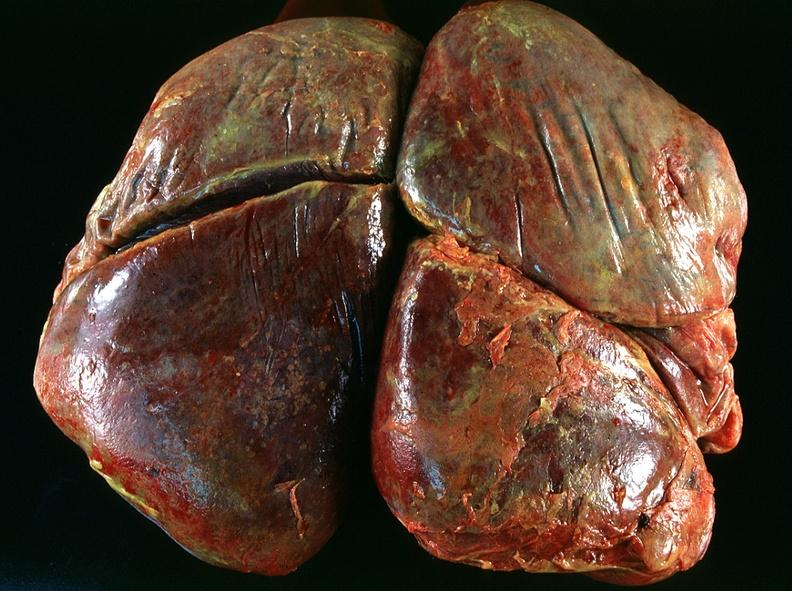s respiratory present?
Answer the question using a single word or phrase. Yes 